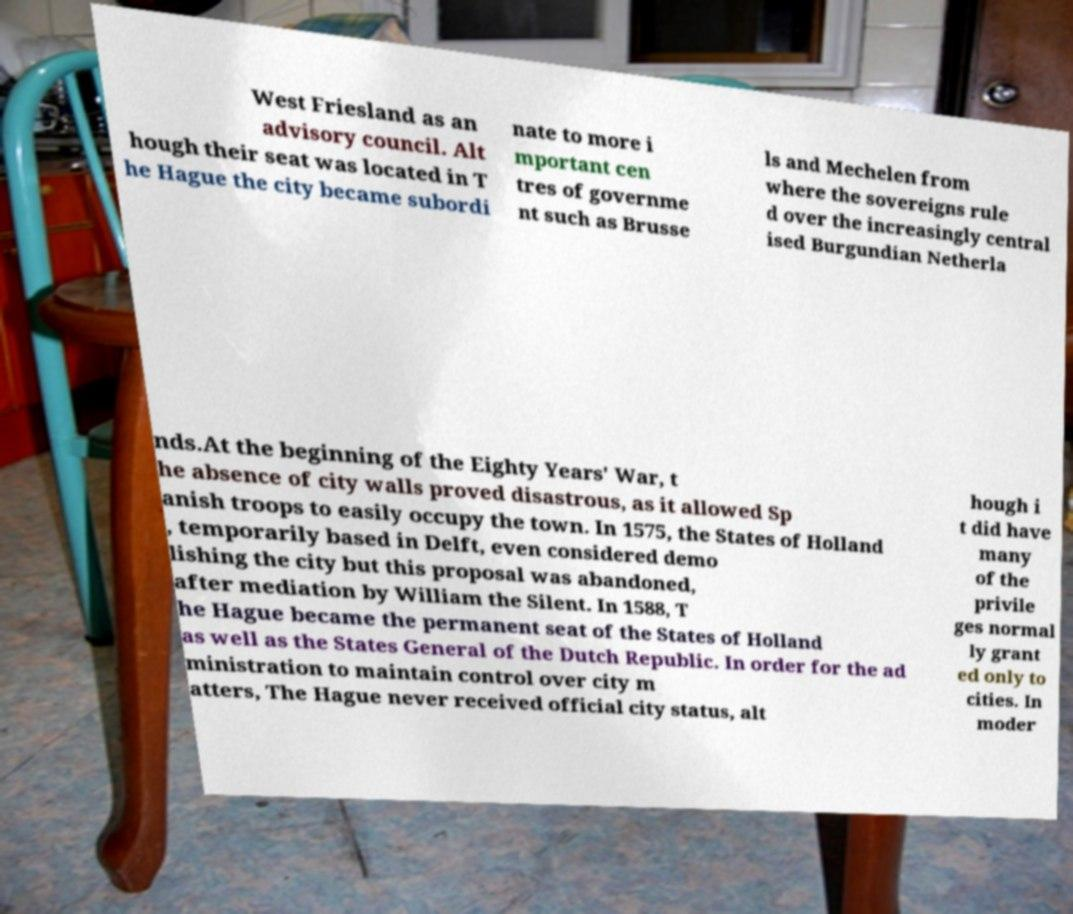Please read and relay the text visible in this image. What does it say? West Friesland as an advisory council. Alt hough their seat was located in T he Hague the city became subordi nate to more i mportant cen tres of governme nt such as Brusse ls and Mechelen from where the sovereigns rule d over the increasingly central ised Burgundian Netherla nds.At the beginning of the Eighty Years' War, t he absence of city walls proved disastrous, as it allowed Sp anish troops to easily occupy the town. In 1575, the States of Holland , temporarily based in Delft, even considered demo lishing the city but this proposal was abandoned, after mediation by William the Silent. In 1588, T he Hague became the permanent seat of the States of Holland as well as the States General of the Dutch Republic. In order for the ad ministration to maintain control over city m atters, The Hague never received official city status, alt hough i t did have many of the privile ges normal ly grant ed only to cities. In moder 